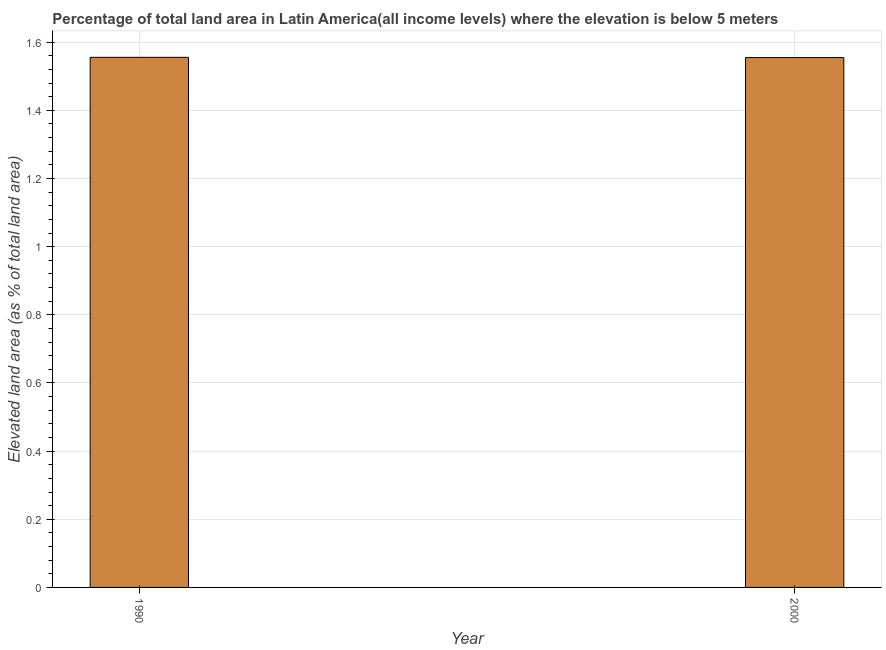Does the graph contain grids?
Provide a short and direct response. Yes. What is the title of the graph?
Keep it short and to the point. Percentage of total land area in Latin America(all income levels) where the elevation is below 5 meters. What is the label or title of the X-axis?
Offer a very short reply. Year. What is the label or title of the Y-axis?
Give a very brief answer. Elevated land area (as % of total land area). What is the total elevated land area in 1990?
Provide a short and direct response. 1.56. Across all years, what is the maximum total elevated land area?
Provide a short and direct response. 1.56. Across all years, what is the minimum total elevated land area?
Give a very brief answer. 1.55. In which year was the total elevated land area minimum?
Your answer should be very brief. 2000. What is the sum of the total elevated land area?
Offer a terse response. 3.11. What is the average total elevated land area per year?
Offer a very short reply. 1.55. What is the median total elevated land area?
Your answer should be compact. 1.56. In how many years, is the total elevated land area greater than 0.8 %?
Your response must be concise. 2. Do a majority of the years between 1990 and 2000 (inclusive) have total elevated land area greater than 0.36 %?
Provide a short and direct response. Yes. What is the ratio of the total elevated land area in 1990 to that in 2000?
Provide a succinct answer. 1. In how many years, is the total elevated land area greater than the average total elevated land area taken over all years?
Offer a terse response. 1. How many bars are there?
Provide a succinct answer. 2. Are all the bars in the graph horizontal?
Offer a very short reply. No. Are the values on the major ticks of Y-axis written in scientific E-notation?
Offer a very short reply. No. What is the Elevated land area (as % of total land area) in 1990?
Provide a short and direct response. 1.56. What is the Elevated land area (as % of total land area) of 2000?
Make the answer very short. 1.55. What is the difference between the Elevated land area (as % of total land area) in 1990 and 2000?
Keep it short and to the point. 0. 